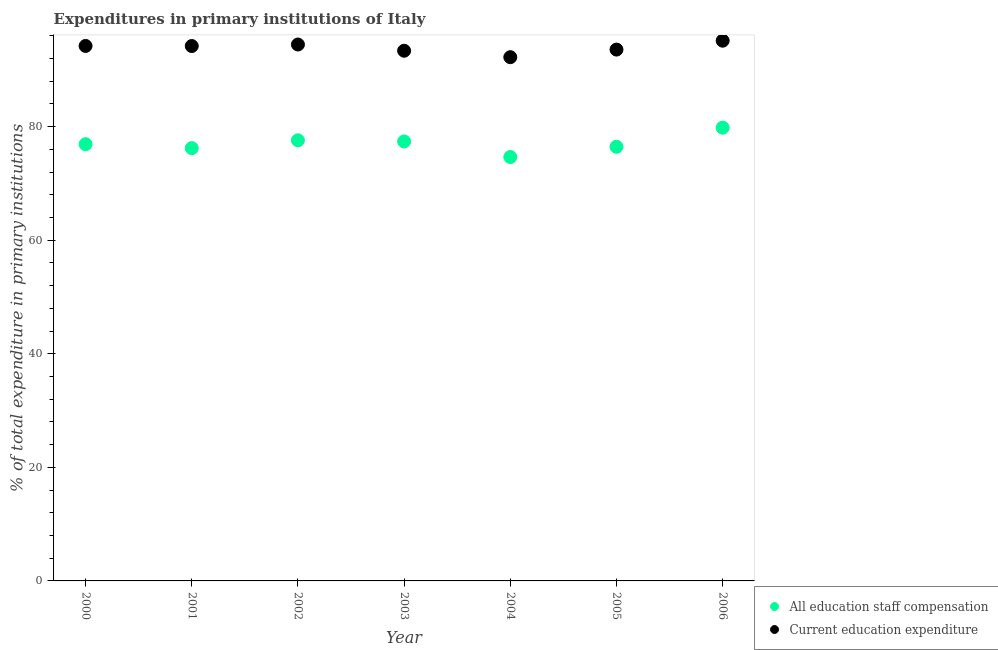What is the expenditure in staff compensation in 2002?
Offer a very short reply. 77.6. Across all years, what is the maximum expenditure in education?
Your answer should be very brief. 95.14. Across all years, what is the minimum expenditure in education?
Offer a very short reply. 92.23. What is the total expenditure in education in the graph?
Provide a succinct answer. 657.18. What is the difference between the expenditure in staff compensation in 2004 and that in 2006?
Keep it short and to the point. -5.17. What is the difference between the expenditure in staff compensation in 2002 and the expenditure in education in 2000?
Provide a succinct answer. -16.61. What is the average expenditure in education per year?
Offer a terse response. 93.88. In the year 2002, what is the difference between the expenditure in staff compensation and expenditure in education?
Provide a succinct answer. -16.87. In how many years, is the expenditure in staff compensation greater than 48 %?
Keep it short and to the point. 7. What is the ratio of the expenditure in staff compensation in 2001 to that in 2004?
Your answer should be very brief. 1.02. What is the difference between the highest and the second highest expenditure in education?
Provide a short and direct response. 0.67. What is the difference between the highest and the lowest expenditure in staff compensation?
Offer a very short reply. 5.17. How many dotlines are there?
Your answer should be compact. 2. What is the difference between two consecutive major ticks on the Y-axis?
Ensure brevity in your answer.  20. Are the values on the major ticks of Y-axis written in scientific E-notation?
Your response must be concise. No. Does the graph contain grids?
Provide a short and direct response. No. How many legend labels are there?
Offer a very short reply. 2. How are the legend labels stacked?
Keep it short and to the point. Vertical. What is the title of the graph?
Provide a short and direct response. Expenditures in primary institutions of Italy. What is the label or title of the Y-axis?
Ensure brevity in your answer.  % of total expenditure in primary institutions. What is the % of total expenditure in primary institutions of All education staff compensation in 2000?
Provide a succinct answer. 76.91. What is the % of total expenditure in primary institutions of Current education expenditure in 2000?
Offer a terse response. 94.21. What is the % of total expenditure in primary institutions in All education staff compensation in 2001?
Keep it short and to the point. 76.22. What is the % of total expenditure in primary institutions in Current education expenditure in 2001?
Provide a short and direct response. 94.2. What is the % of total expenditure in primary institutions in All education staff compensation in 2002?
Your response must be concise. 77.6. What is the % of total expenditure in primary institutions of Current education expenditure in 2002?
Give a very brief answer. 94.46. What is the % of total expenditure in primary institutions of All education staff compensation in 2003?
Keep it short and to the point. 77.4. What is the % of total expenditure in primary institutions in Current education expenditure in 2003?
Provide a succinct answer. 93.37. What is the % of total expenditure in primary institutions of All education staff compensation in 2004?
Your response must be concise. 74.65. What is the % of total expenditure in primary institutions of Current education expenditure in 2004?
Provide a succinct answer. 92.23. What is the % of total expenditure in primary institutions in All education staff compensation in 2005?
Make the answer very short. 76.46. What is the % of total expenditure in primary institutions of Current education expenditure in 2005?
Offer a terse response. 93.57. What is the % of total expenditure in primary institutions in All education staff compensation in 2006?
Provide a succinct answer. 79.82. What is the % of total expenditure in primary institutions of Current education expenditure in 2006?
Make the answer very short. 95.14. Across all years, what is the maximum % of total expenditure in primary institutions in All education staff compensation?
Offer a terse response. 79.82. Across all years, what is the maximum % of total expenditure in primary institutions in Current education expenditure?
Your answer should be very brief. 95.14. Across all years, what is the minimum % of total expenditure in primary institutions of All education staff compensation?
Ensure brevity in your answer.  74.65. Across all years, what is the minimum % of total expenditure in primary institutions in Current education expenditure?
Offer a terse response. 92.23. What is the total % of total expenditure in primary institutions of All education staff compensation in the graph?
Ensure brevity in your answer.  539.05. What is the total % of total expenditure in primary institutions in Current education expenditure in the graph?
Provide a succinct answer. 657.18. What is the difference between the % of total expenditure in primary institutions in All education staff compensation in 2000 and that in 2001?
Your response must be concise. 0.69. What is the difference between the % of total expenditure in primary institutions in Current education expenditure in 2000 and that in 2001?
Your response must be concise. 0.01. What is the difference between the % of total expenditure in primary institutions of All education staff compensation in 2000 and that in 2002?
Keep it short and to the point. -0.69. What is the difference between the % of total expenditure in primary institutions in Current education expenditure in 2000 and that in 2002?
Ensure brevity in your answer.  -0.25. What is the difference between the % of total expenditure in primary institutions in All education staff compensation in 2000 and that in 2003?
Provide a succinct answer. -0.48. What is the difference between the % of total expenditure in primary institutions in Current education expenditure in 2000 and that in 2003?
Give a very brief answer. 0.84. What is the difference between the % of total expenditure in primary institutions in All education staff compensation in 2000 and that in 2004?
Keep it short and to the point. 2.26. What is the difference between the % of total expenditure in primary institutions of Current education expenditure in 2000 and that in 2004?
Make the answer very short. 1.98. What is the difference between the % of total expenditure in primary institutions of All education staff compensation in 2000 and that in 2005?
Make the answer very short. 0.45. What is the difference between the % of total expenditure in primary institutions of Current education expenditure in 2000 and that in 2005?
Give a very brief answer. 0.64. What is the difference between the % of total expenditure in primary institutions in All education staff compensation in 2000 and that in 2006?
Keep it short and to the point. -2.91. What is the difference between the % of total expenditure in primary institutions in Current education expenditure in 2000 and that in 2006?
Offer a very short reply. -0.93. What is the difference between the % of total expenditure in primary institutions in All education staff compensation in 2001 and that in 2002?
Your answer should be very brief. -1.38. What is the difference between the % of total expenditure in primary institutions in Current education expenditure in 2001 and that in 2002?
Ensure brevity in your answer.  -0.27. What is the difference between the % of total expenditure in primary institutions of All education staff compensation in 2001 and that in 2003?
Provide a succinct answer. -1.18. What is the difference between the % of total expenditure in primary institutions of Current education expenditure in 2001 and that in 2003?
Provide a succinct answer. 0.83. What is the difference between the % of total expenditure in primary institutions in All education staff compensation in 2001 and that in 2004?
Your response must be concise. 1.57. What is the difference between the % of total expenditure in primary institutions of Current education expenditure in 2001 and that in 2004?
Provide a succinct answer. 1.96. What is the difference between the % of total expenditure in primary institutions in All education staff compensation in 2001 and that in 2005?
Offer a terse response. -0.24. What is the difference between the % of total expenditure in primary institutions in Current education expenditure in 2001 and that in 2005?
Keep it short and to the point. 0.63. What is the difference between the % of total expenditure in primary institutions of All education staff compensation in 2001 and that in 2006?
Keep it short and to the point. -3.6. What is the difference between the % of total expenditure in primary institutions in Current education expenditure in 2001 and that in 2006?
Your answer should be compact. -0.94. What is the difference between the % of total expenditure in primary institutions of All education staff compensation in 2002 and that in 2003?
Offer a terse response. 0.2. What is the difference between the % of total expenditure in primary institutions of Current education expenditure in 2002 and that in 2003?
Ensure brevity in your answer.  1.09. What is the difference between the % of total expenditure in primary institutions in All education staff compensation in 2002 and that in 2004?
Your response must be concise. 2.95. What is the difference between the % of total expenditure in primary institutions of Current education expenditure in 2002 and that in 2004?
Your answer should be compact. 2.23. What is the difference between the % of total expenditure in primary institutions in All education staff compensation in 2002 and that in 2005?
Your response must be concise. 1.14. What is the difference between the % of total expenditure in primary institutions of Current education expenditure in 2002 and that in 2005?
Your answer should be very brief. 0.89. What is the difference between the % of total expenditure in primary institutions in All education staff compensation in 2002 and that in 2006?
Your answer should be compact. -2.22. What is the difference between the % of total expenditure in primary institutions of Current education expenditure in 2002 and that in 2006?
Give a very brief answer. -0.67. What is the difference between the % of total expenditure in primary institutions in All education staff compensation in 2003 and that in 2004?
Your answer should be very brief. 2.75. What is the difference between the % of total expenditure in primary institutions in Current education expenditure in 2003 and that in 2004?
Your answer should be very brief. 1.14. What is the difference between the % of total expenditure in primary institutions of All education staff compensation in 2003 and that in 2005?
Keep it short and to the point. 0.94. What is the difference between the % of total expenditure in primary institutions in Current education expenditure in 2003 and that in 2005?
Give a very brief answer. -0.2. What is the difference between the % of total expenditure in primary institutions in All education staff compensation in 2003 and that in 2006?
Your response must be concise. -2.42. What is the difference between the % of total expenditure in primary institutions of Current education expenditure in 2003 and that in 2006?
Offer a very short reply. -1.77. What is the difference between the % of total expenditure in primary institutions in All education staff compensation in 2004 and that in 2005?
Offer a terse response. -1.81. What is the difference between the % of total expenditure in primary institutions of Current education expenditure in 2004 and that in 2005?
Provide a short and direct response. -1.34. What is the difference between the % of total expenditure in primary institutions in All education staff compensation in 2004 and that in 2006?
Your response must be concise. -5.17. What is the difference between the % of total expenditure in primary institutions of Current education expenditure in 2004 and that in 2006?
Offer a terse response. -2.9. What is the difference between the % of total expenditure in primary institutions of All education staff compensation in 2005 and that in 2006?
Ensure brevity in your answer.  -3.36. What is the difference between the % of total expenditure in primary institutions of Current education expenditure in 2005 and that in 2006?
Offer a terse response. -1.57. What is the difference between the % of total expenditure in primary institutions of All education staff compensation in 2000 and the % of total expenditure in primary institutions of Current education expenditure in 2001?
Make the answer very short. -17.29. What is the difference between the % of total expenditure in primary institutions of All education staff compensation in 2000 and the % of total expenditure in primary institutions of Current education expenditure in 2002?
Make the answer very short. -17.55. What is the difference between the % of total expenditure in primary institutions of All education staff compensation in 2000 and the % of total expenditure in primary institutions of Current education expenditure in 2003?
Provide a short and direct response. -16.46. What is the difference between the % of total expenditure in primary institutions in All education staff compensation in 2000 and the % of total expenditure in primary institutions in Current education expenditure in 2004?
Make the answer very short. -15.32. What is the difference between the % of total expenditure in primary institutions of All education staff compensation in 2000 and the % of total expenditure in primary institutions of Current education expenditure in 2005?
Offer a very short reply. -16.66. What is the difference between the % of total expenditure in primary institutions of All education staff compensation in 2000 and the % of total expenditure in primary institutions of Current education expenditure in 2006?
Keep it short and to the point. -18.23. What is the difference between the % of total expenditure in primary institutions in All education staff compensation in 2001 and the % of total expenditure in primary institutions in Current education expenditure in 2002?
Ensure brevity in your answer.  -18.24. What is the difference between the % of total expenditure in primary institutions in All education staff compensation in 2001 and the % of total expenditure in primary institutions in Current education expenditure in 2003?
Make the answer very short. -17.15. What is the difference between the % of total expenditure in primary institutions of All education staff compensation in 2001 and the % of total expenditure in primary institutions of Current education expenditure in 2004?
Your answer should be compact. -16.01. What is the difference between the % of total expenditure in primary institutions in All education staff compensation in 2001 and the % of total expenditure in primary institutions in Current education expenditure in 2005?
Provide a succinct answer. -17.35. What is the difference between the % of total expenditure in primary institutions of All education staff compensation in 2001 and the % of total expenditure in primary institutions of Current education expenditure in 2006?
Your answer should be compact. -18.92. What is the difference between the % of total expenditure in primary institutions of All education staff compensation in 2002 and the % of total expenditure in primary institutions of Current education expenditure in 2003?
Your response must be concise. -15.77. What is the difference between the % of total expenditure in primary institutions in All education staff compensation in 2002 and the % of total expenditure in primary institutions in Current education expenditure in 2004?
Your response must be concise. -14.64. What is the difference between the % of total expenditure in primary institutions of All education staff compensation in 2002 and the % of total expenditure in primary institutions of Current education expenditure in 2005?
Offer a terse response. -15.97. What is the difference between the % of total expenditure in primary institutions of All education staff compensation in 2002 and the % of total expenditure in primary institutions of Current education expenditure in 2006?
Ensure brevity in your answer.  -17.54. What is the difference between the % of total expenditure in primary institutions of All education staff compensation in 2003 and the % of total expenditure in primary institutions of Current education expenditure in 2004?
Offer a very short reply. -14.84. What is the difference between the % of total expenditure in primary institutions in All education staff compensation in 2003 and the % of total expenditure in primary institutions in Current education expenditure in 2005?
Make the answer very short. -16.17. What is the difference between the % of total expenditure in primary institutions in All education staff compensation in 2003 and the % of total expenditure in primary institutions in Current education expenditure in 2006?
Make the answer very short. -17.74. What is the difference between the % of total expenditure in primary institutions in All education staff compensation in 2004 and the % of total expenditure in primary institutions in Current education expenditure in 2005?
Keep it short and to the point. -18.92. What is the difference between the % of total expenditure in primary institutions in All education staff compensation in 2004 and the % of total expenditure in primary institutions in Current education expenditure in 2006?
Offer a very short reply. -20.49. What is the difference between the % of total expenditure in primary institutions of All education staff compensation in 2005 and the % of total expenditure in primary institutions of Current education expenditure in 2006?
Offer a terse response. -18.68. What is the average % of total expenditure in primary institutions in All education staff compensation per year?
Your answer should be very brief. 77.01. What is the average % of total expenditure in primary institutions in Current education expenditure per year?
Ensure brevity in your answer.  93.88. In the year 2000, what is the difference between the % of total expenditure in primary institutions of All education staff compensation and % of total expenditure in primary institutions of Current education expenditure?
Offer a very short reply. -17.3. In the year 2001, what is the difference between the % of total expenditure in primary institutions in All education staff compensation and % of total expenditure in primary institutions in Current education expenditure?
Provide a short and direct response. -17.98. In the year 2002, what is the difference between the % of total expenditure in primary institutions of All education staff compensation and % of total expenditure in primary institutions of Current education expenditure?
Keep it short and to the point. -16.87. In the year 2003, what is the difference between the % of total expenditure in primary institutions of All education staff compensation and % of total expenditure in primary institutions of Current education expenditure?
Provide a short and direct response. -15.97. In the year 2004, what is the difference between the % of total expenditure in primary institutions in All education staff compensation and % of total expenditure in primary institutions in Current education expenditure?
Provide a succinct answer. -17.58. In the year 2005, what is the difference between the % of total expenditure in primary institutions in All education staff compensation and % of total expenditure in primary institutions in Current education expenditure?
Your answer should be very brief. -17.11. In the year 2006, what is the difference between the % of total expenditure in primary institutions in All education staff compensation and % of total expenditure in primary institutions in Current education expenditure?
Provide a succinct answer. -15.32. What is the ratio of the % of total expenditure in primary institutions of All education staff compensation in 2000 to that in 2001?
Provide a short and direct response. 1.01. What is the ratio of the % of total expenditure in primary institutions of All education staff compensation in 2000 to that in 2002?
Your answer should be very brief. 0.99. What is the ratio of the % of total expenditure in primary institutions of Current education expenditure in 2000 to that in 2003?
Offer a very short reply. 1.01. What is the ratio of the % of total expenditure in primary institutions of All education staff compensation in 2000 to that in 2004?
Offer a terse response. 1.03. What is the ratio of the % of total expenditure in primary institutions in Current education expenditure in 2000 to that in 2004?
Your answer should be very brief. 1.02. What is the ratio of the % of total expenditure in primary institutions in All education staff compensation in 2000 to that in 2005?
Offer a terse response. 1.01. What is the ratio of the % of total expenditure in primary institutions in Current education expenditure in 2000 to that in 2005?
Give a very brief answer. 1.01. What is the ratio of the % of total expenditure in primary institutions in All education staff compensation in 2000 to that in 2006?
Offer a terse response. 0.96. What is the ratio of the % of total expenditure in primary institutions in Current education expenditure in 2000 to that in 2006?
Keep it short and to the point. 0.99. What is the ratio of the % of total expenditure in primary institutions in All education staff compensation in 2001 to that in 2002?
Your answer should be compact. 0.98. What is the ratio of the % of total expenditure in primary institutions of Current education expenditure in 2001 to that in 2002?
Give a very brief answer. 1. What is the ratio of the % of total expenditure in primary institutions of All education staff compensation in 2001 to that in 2003?
Provide a short and direct response. 0.98. What is the ratio of the % of total expenditure in primary institutions in Current education expenditure in 2001 to that in 2003?
Your answer should be compact. 1.01. What is the ratio of the % of total expenditure in primary institutions in Current education expenditure in 2001 to that in 2004?
Make the answer very short. 1.02. What is the ratio of the % of total expenditure in primary institutions of All education staff compensation in 2001 to that in 2005?
Give a very brief answer. 1. What is the ratio of the % of total expenditure in primary institutions of All education staff compensation in 2001 to that in 2006?
Provide a short and direct response. 0.95. What is the ratio of the % of total expenditure in primary institutions of All education staff compensation in 2002 to that in 2003?
Make the answer very short. 1. What is the ratio of the % of total expenditure in primary institutions in Current education expenditure in 2002 to that in 2003?
Your answer should be very brief. 1.01. What is the ratio of the % of total expenditure in primary institutions in All education staff compensation in 2002 to that in 2004?
Ensure brevity in your answer.  1.04. What is the ratio of the % of total expenditure in primary institutions of Current education expenditure in 2002 to that in 2004?
Make the answer very short. 1.02. What is the ratio of the % of total expenditure in primary institutions of All education staff compensation in 2002 to that in 2005?
Your response must be concise. 1.01. What is the ratio of the % of total expenditure in primary institutions in Current education expenditure in 2002 to that in 2005?
Offer a terse response. 1.01. What is the ratio of the % of total expenditure in primary institutions of All education staff compensation in 2002 to that in 2006?
Keep it short and to the point. 0.97. What is the ratio of the % of total expenditure in primary institutions of Current education expenditure in 2002 to that in 2006?
Keep it short and to the point. 0.99. What is the ratio of the % of total expenditure in primary institutions in All education staff compensation in 2003 to that in 2004?
Provide a short and direct response. 1.04. What is the ratio of the % of total expenditure in primary institutions of Current education expenditure in 2003 to that in 2004?
Provide a short and direct response. 1.01. What is the ratio of the % of total expenditure in primary institutions of All education staff compensation in 2003 to that in 2005?
Keep it short and to the point. 1.01. What is the ratio of the % of total expenditure in primary institutions of Current education expenditure in 2003 to that in 2005?
Give a very brief answer. 1. What is the ratio of the % of total expenditure in primary institutions of All education staff compensation in 2003 to that in 2006?
Your answer should be compact. 0.97. What is the ratio of the % of total expenditure in primary institutions of Current education expenditure in 2003 to that in 2006?
Provide a succinct answer. 0.98. What is the ratio of the % of total expenditure in primary institutions in All education staff compensation in 2004 to that in 2005?
Offer a terse response. 0.98. What is the ratio of the % of total expenditure in primary institutions in Current education expenditure in 2004 to that in 2005?
Offer a terse response. 0.99. What is the ratio of the % of total expenditure in primary institutions of All education staff compensation in 2004 to that in 2006?
Your answer should be very brief. 0.94. What is the ratio of the % of total expenditure in primary institutions of Current education expenditure in 2004 to that in 2006?
Your answer should be very brief. 0.97. What is the ratio of the % of total expenditure in primary institutions in All education staff compensation in 2005 to that in 2006?
Give a very brief answer. 0.96. What is the ratio of the % of total expenditure in primary institutions of Current education expenditure in 2005 to that in 2006?
Provide a succinct answer. 0.98. What is the difference between the highest and the second highest % of total expenditure in primary institutions of All education staff compensation?
Offer a very short reply. 2.22. What is the difference between the highest and the second highest % of total expenditure in primary institutions in Current education expenditure?
Offer a very short reply. 0.67. What is the difference between the highest and the lowest % of total expenditure in primary institutions in All education staff compensation?
Your response must be concise. 5.17. What is the difference between the highest and the lowest % of total expenditure in primary institutions in Current education expenditure?
Keep it short and to the point. 2.9. 